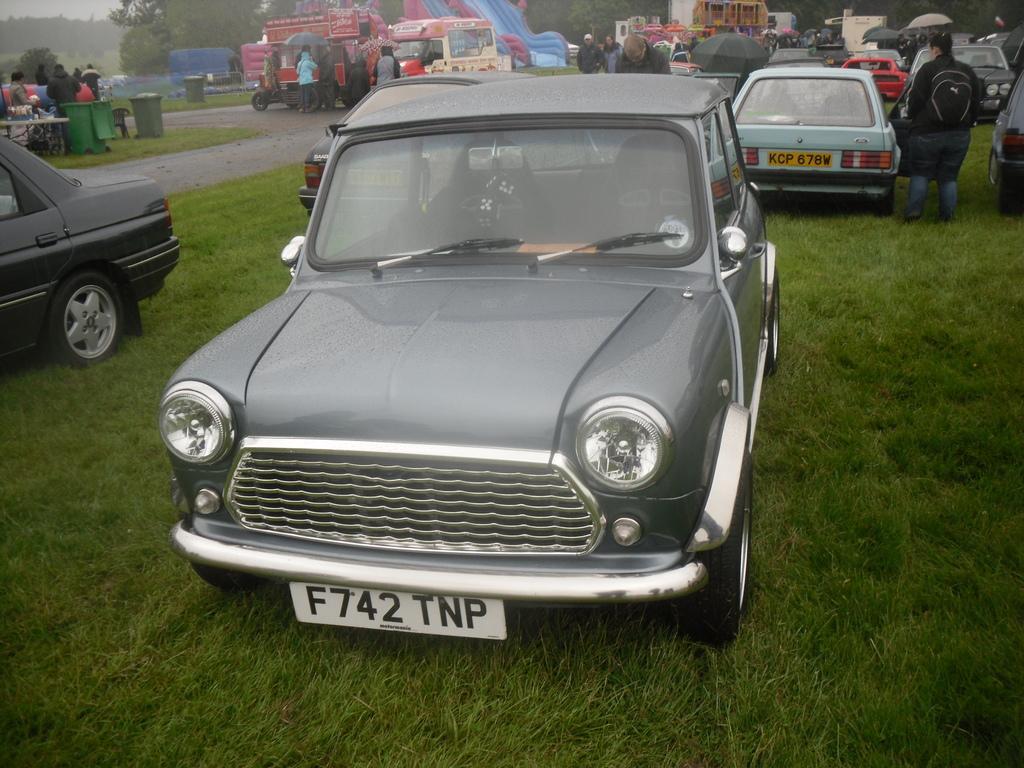How would you summarize this image in a sentence or two? In this image we can see a few cars parked on the ground, road, a few people standing on the ground and in the background there are some trees and a sky. 